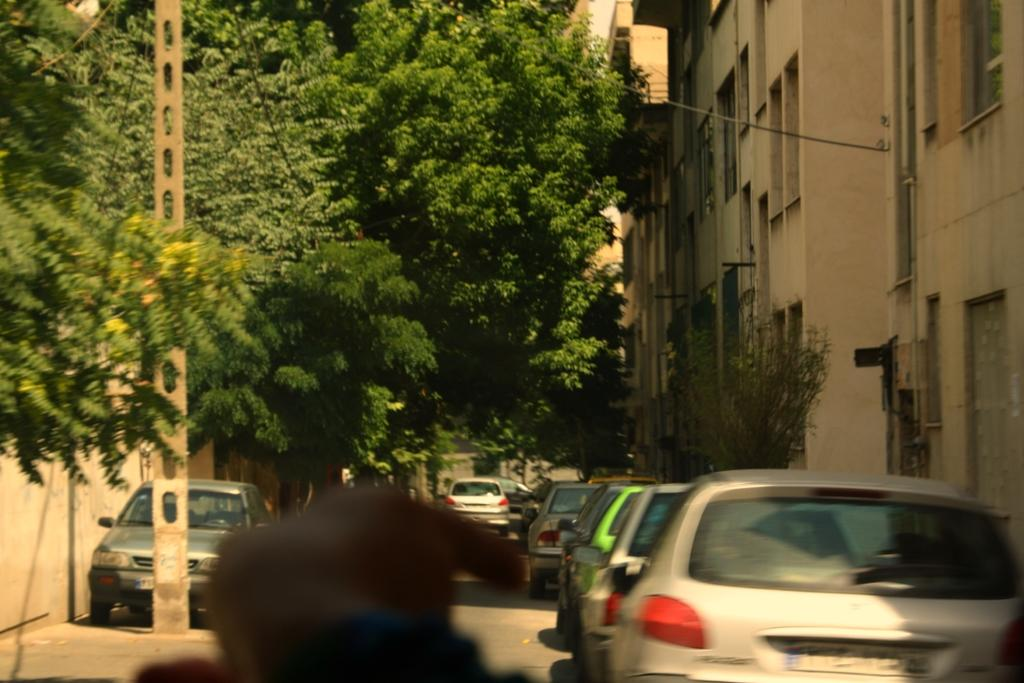What types of objects can be seen in the image? There are vehicles, buildings, trees, wires, windows, and a pole in the image. Can you describe the buildings in the image? The buildings in the image have windows. What else can be found in the image besides the buildings? There are trees, wires, and a pole in the image. What type of powder is being used to clean the windows in the image? There is no indication in the image that any powder is being used to clean the windows. How many rabbits can be seen in the image? There are no rabbits present in the image. 